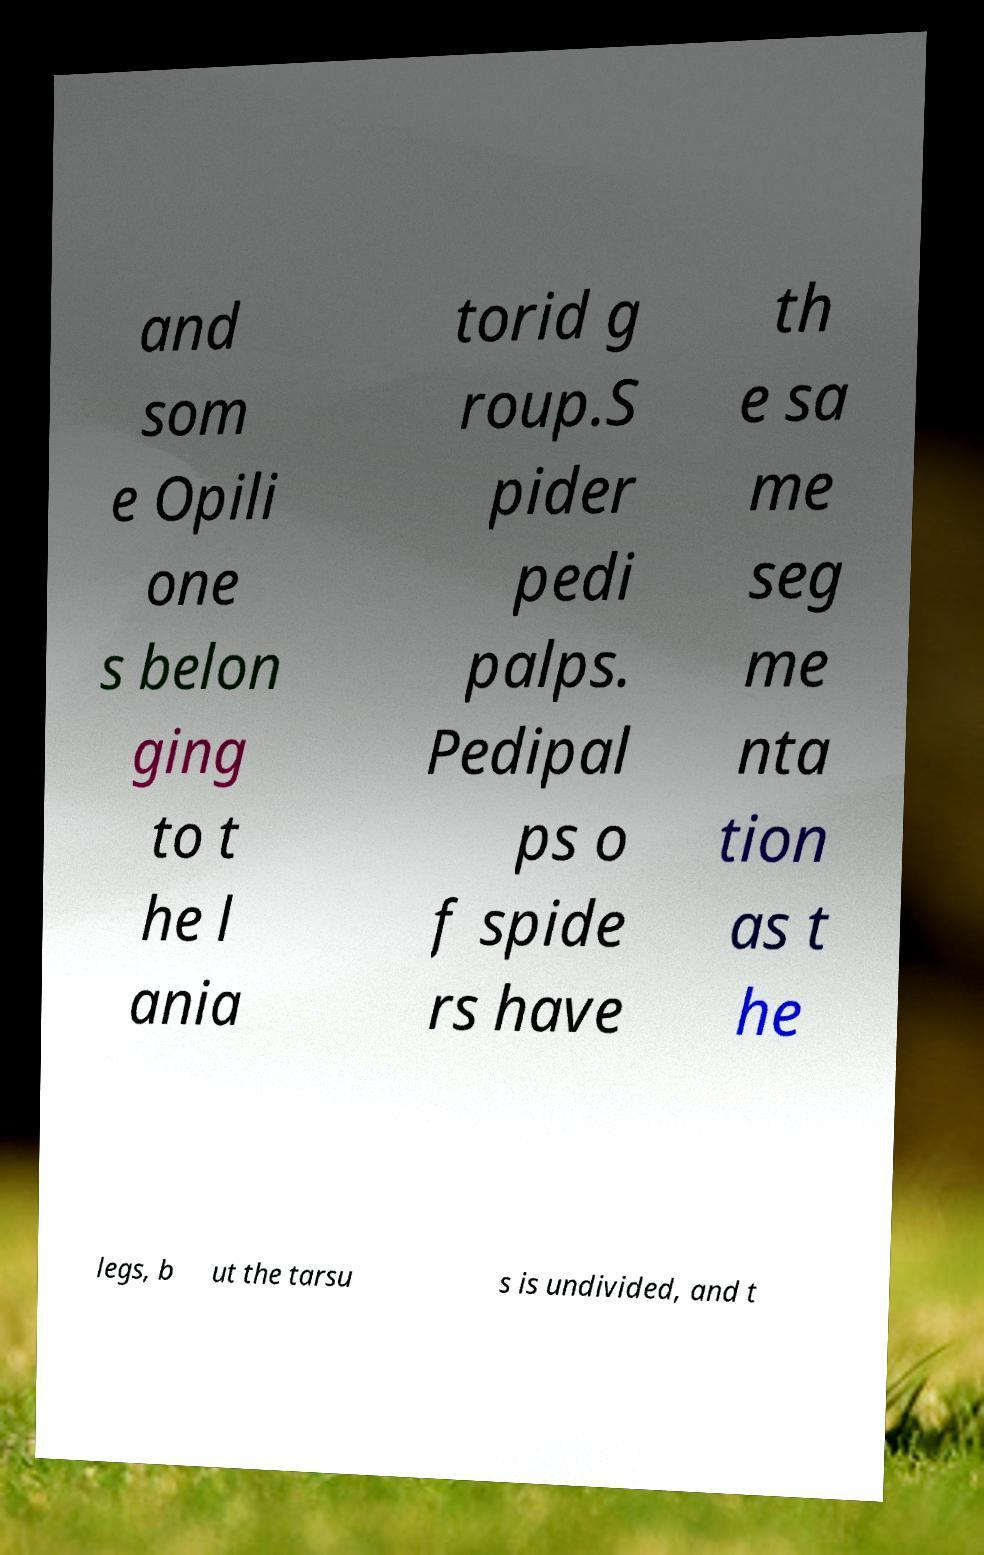Please read and relay the text visible in this image. What does it say? and som e Opili one s belon ging to t he l ania torid g roup.S pider pedi palps. Pedipal ps o f spide rs have th e sa me seg me nta tion as t he legs, b ut the tarsu s is undivided, and t 